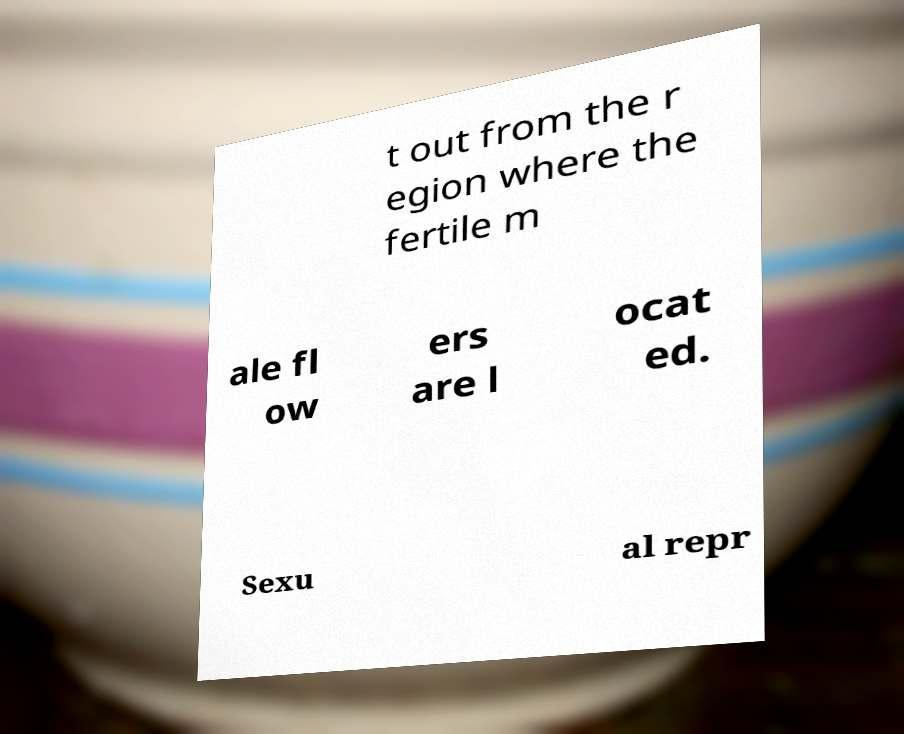Please read and relay the text visible in this image. What does it say? t out from the r egion where the fertile m ale fl ow ers are l ocat ed. Sexu al repr 